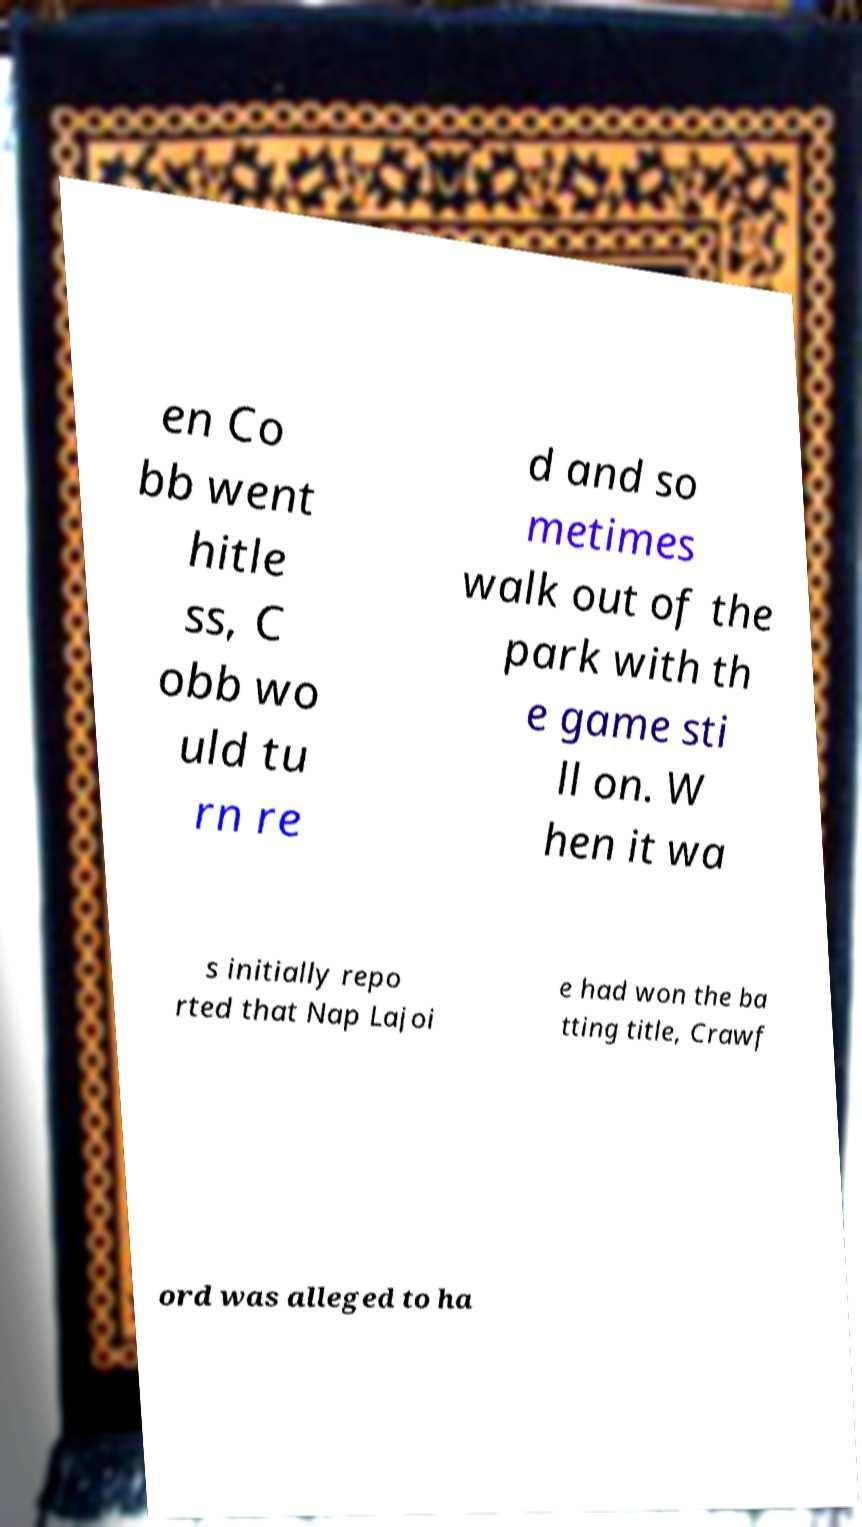There's text embedded in this image that I need extracted. Can you transcribe it verbatim? en Co bb went hitle ss, C obb wo uld tu rn re d and so metimes walk out of the park with th e game sti ll on. W hen it wa s initially repo rted that Nap Lajoi e had won the ba tting title, Crawf ord was alleged to ha 